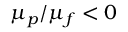<formula> <loc_0><loc_0><loc_500><loc_500>\mu _ { p } / \mu _ { f } < 0</formula> 